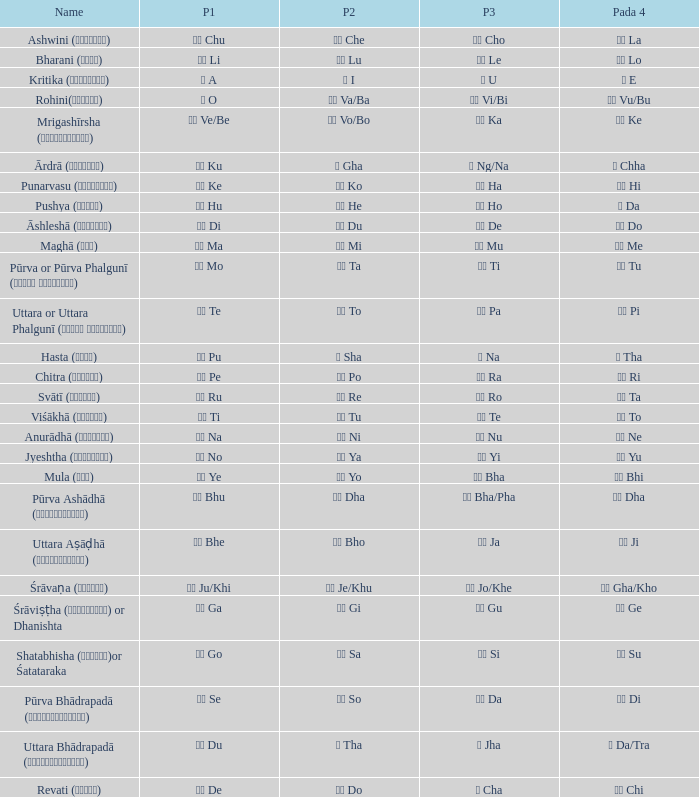What kind of Pada 1 has a Pada 2 of सा sa? गो Go. 